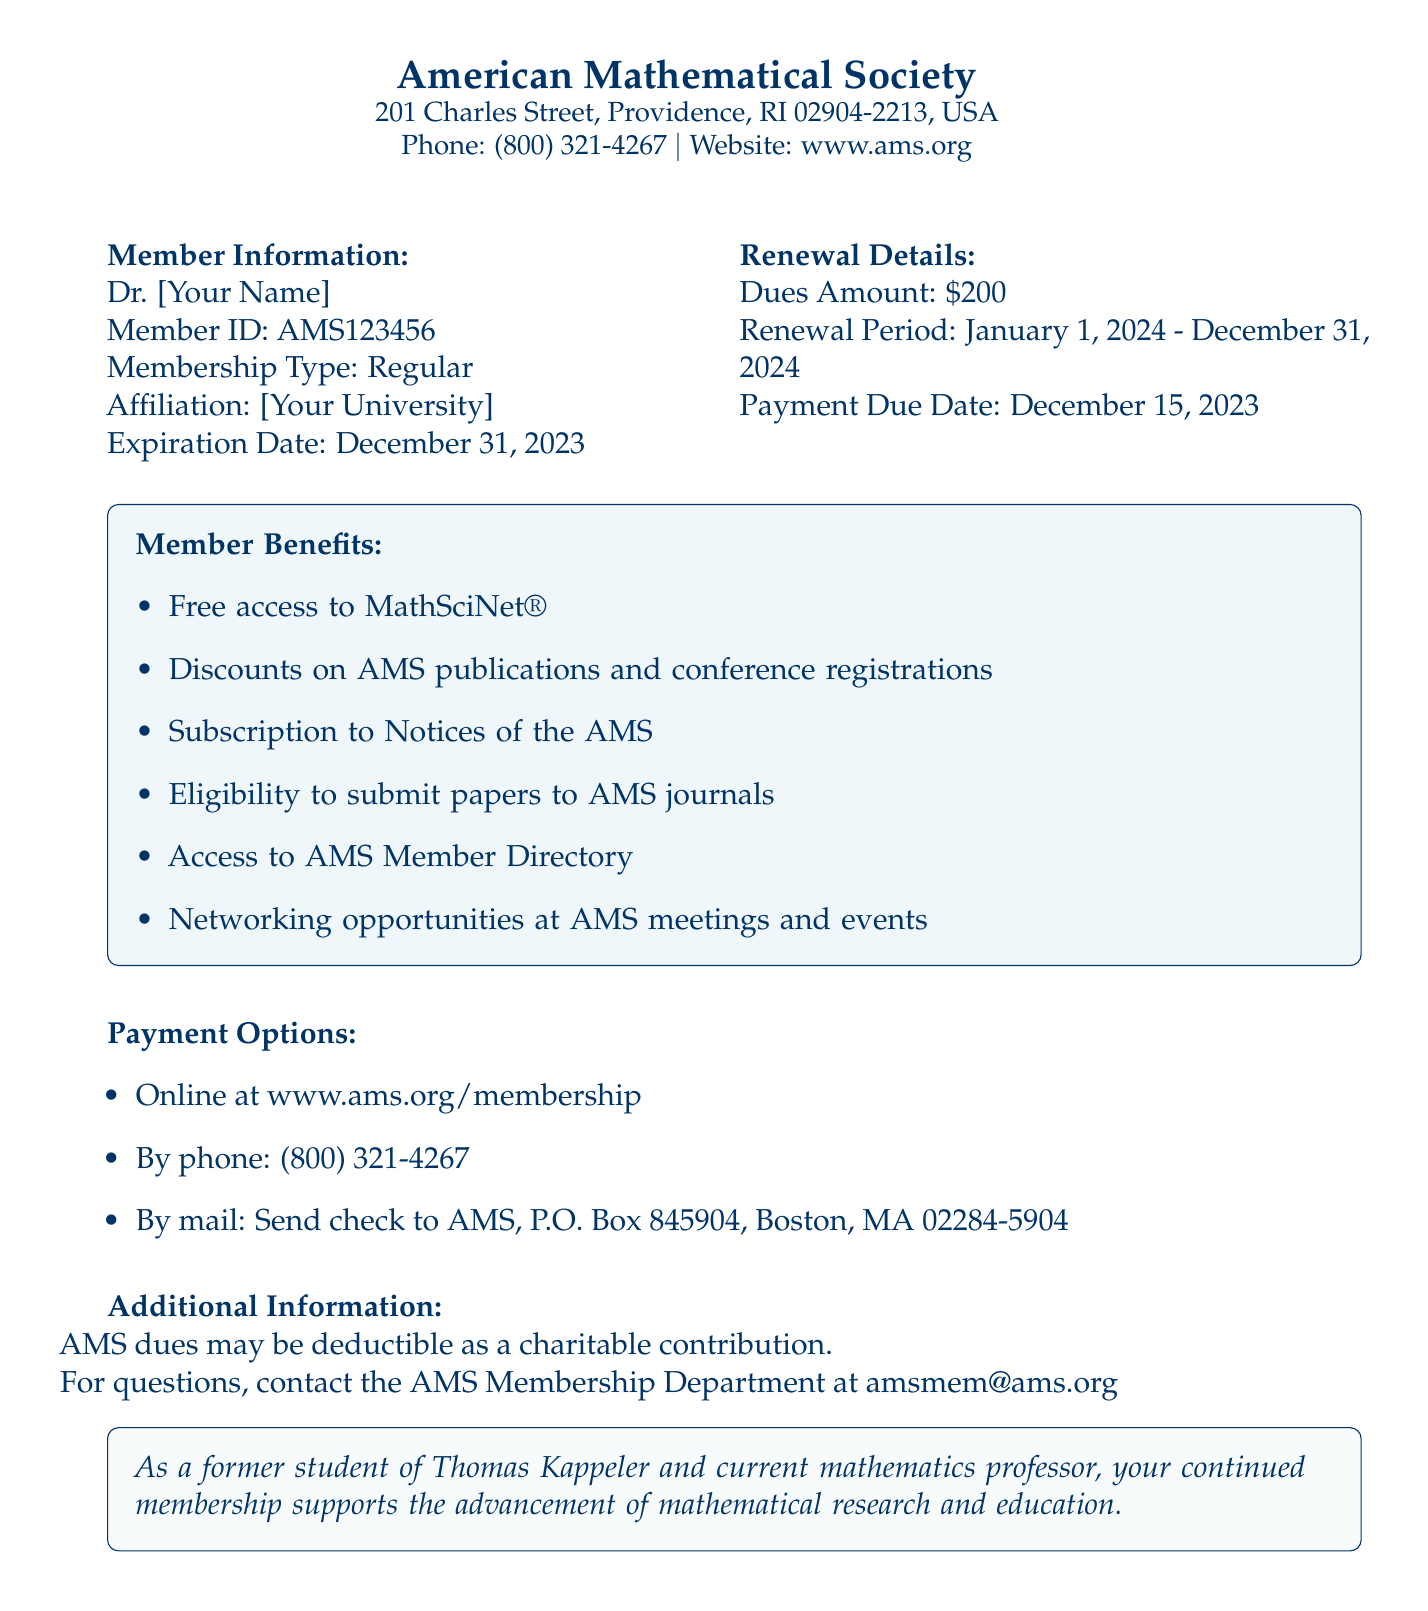What is the member ID? The member ID is specified in the document under the Member Information section as AMS123456.
Answer: AMS123456 What is the dues amount for renewal? The dues amount is noted in the Renewal Details section, which specifies that it is $200.
Answer: $200 What is the expiration date of the membership? The expiration date is found in the Member Information section, indicating the membership expires on December 31, 2023.
Answer: December 31, 2023 What are the benefits of membership? The benefits are listed in a dedicated block within the document, summarizing the advantages of being an AMS member.
Answer: Free access to MathSciNet®, Discounts on AMS publications and conference registrations, Subscription to Notices of the AMS, Eligibility to submit papers to AMS journals, Access to AMS Member Directory, Networking opportunities at AMS meetings and events What is the payment due date? The payment due date is mentioned in the Renewal Details section, specifying the final date by which payment must be made.
Answer: December 15, 2023 How can members pay their dues? Payment options are listed in the document, outlining the available methods for paying dues.
Answer: Online at www.ams.org/membership, By phone: (800) 321-4267, By mail: Send check to AMS, P.O. Box 845904, Boston, MA 02284-5904 What period does the renewal cover? The renewal period is indicated in the Renewal Details section, outlining the duration for which the membership will be active after renewal.
Answer: January 1, 2024 - December 31, 2024 Who can be contacted for questions regarding membership? The contact information for membership questions is provided in the Additional Information section, indicating whom to reach for inquiries.
Answer: AMS Membership Department at amsmem@ams.org 